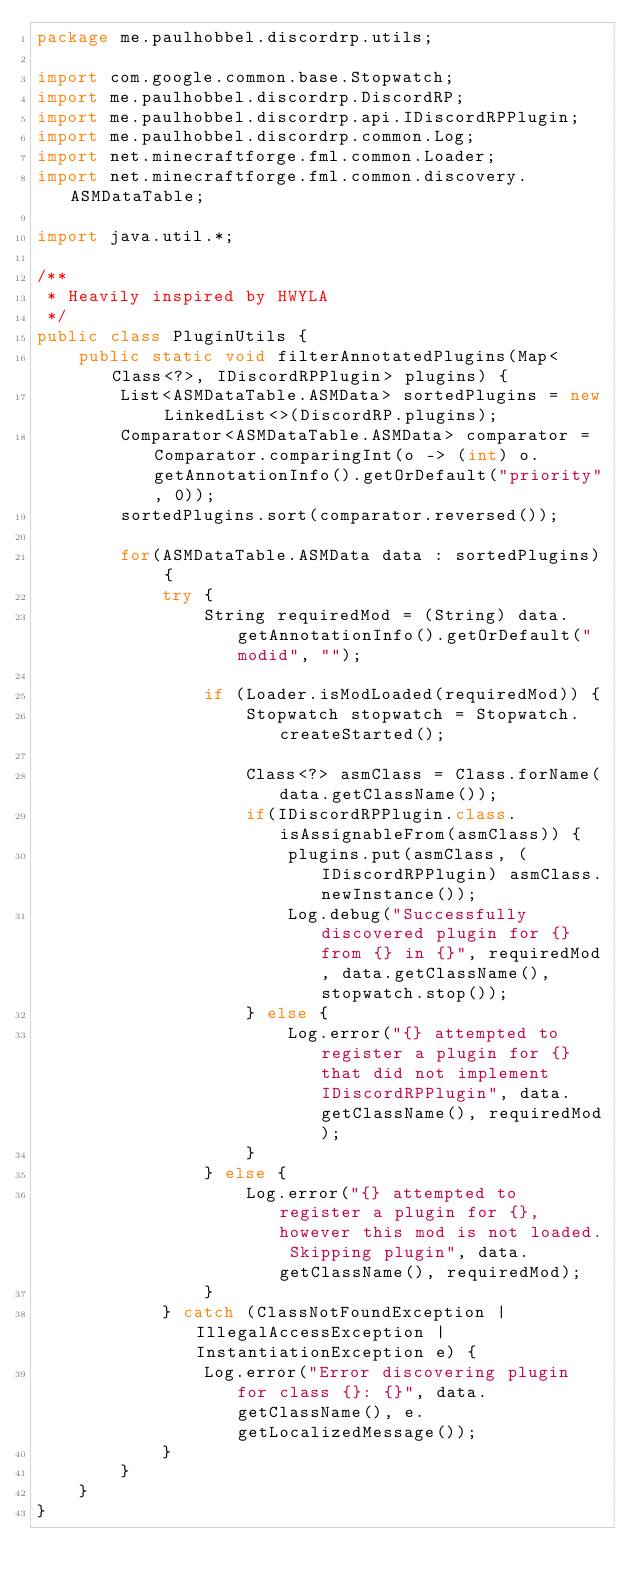<code> <loc_0><loc_0><loc_500><loc_500><_Java_>package me.paulhobbel.discordrp.utils;

import com.google.common.base.Stopwatch;
import me.paulhobbel.discordrp.DiscordRP;
import me.paulhobbel.discordrp.api.IDiscordRPPlugin;
import me.paulhobbel.discordrp.common.Log;
import net.minecraftforge.fml.common.Loader;
import net.minecraftforge.fml.common.discovery.ASMDataTable;

import java.util.*;

/**
 * Heavily inspired by HWYLA
 */
public class PluginUtils {
    public static void filterAnnotatedPlugins(Map<Class<?>, IDiscordRPPlugin> plugins) {
        List<ASMDataTable.ASMData> sortedPlugins = new LinkedList<>(DiscordRP.plugins);
        Comparator<ASMDataTable.ASMData> comparator = Comparator.comparingInt(o -> (int) o.getAnnotationInfo().getOrDefault("priority", 0));
        sortedPlugins.sort(comparator.reversed());

        for(ASMDataTable.ASMData data : sortedPlugins) {
            try {
                String requiredMod = (String) data.getAnnotationInfo().getOrDefault("modid", "");

                if (Loader.isModLoaded(requiredMod)) {
                    Stopwatch stopwatch = Stopwatch.createStarted();

                    Class<?> asmClass = Class.forName(data.getClassName());
                    if(IDiscordRPPlugin.class.isAssignableFrom(asmClass)) {
                        plugins.put(asmClass, (IDiscordRPPlugin) asmClass.newInstance());
                        Log.debug("Successfully discovered plugin for {} from {} in {}", requiredMod, data.getClassName(), stopwatch.stop());
                    } else {
                        Log.error("{} attempted to register a plugin for {} that did not implement IDiscordRPPlugin", data.getClassName(), requiredMod);
                    }
                } else {
                    Log.error("{} attempted to register a plugin for {}, however this mod is not loaded. Skipping plugin", data.getClassName(), requiredMod);
                }
            } catch (ClassNotFoundException | IllegalAccessException | InstantiationException e) {
                Log.error("Error discovering plugin for class {}: {}", data.getClassName(), e.getLocalizedMessage());
            }
        }
    }
}
</code> 